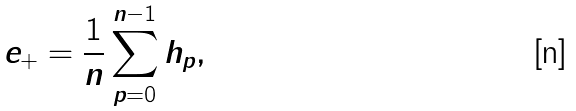<formula> <loc_0><loc_0><loc_500><loc_500>e _ { + } = \frac { 1 } { n } \sum _ { p = 0 } ^ { n - 1 } h _ { p } ,</formula> 